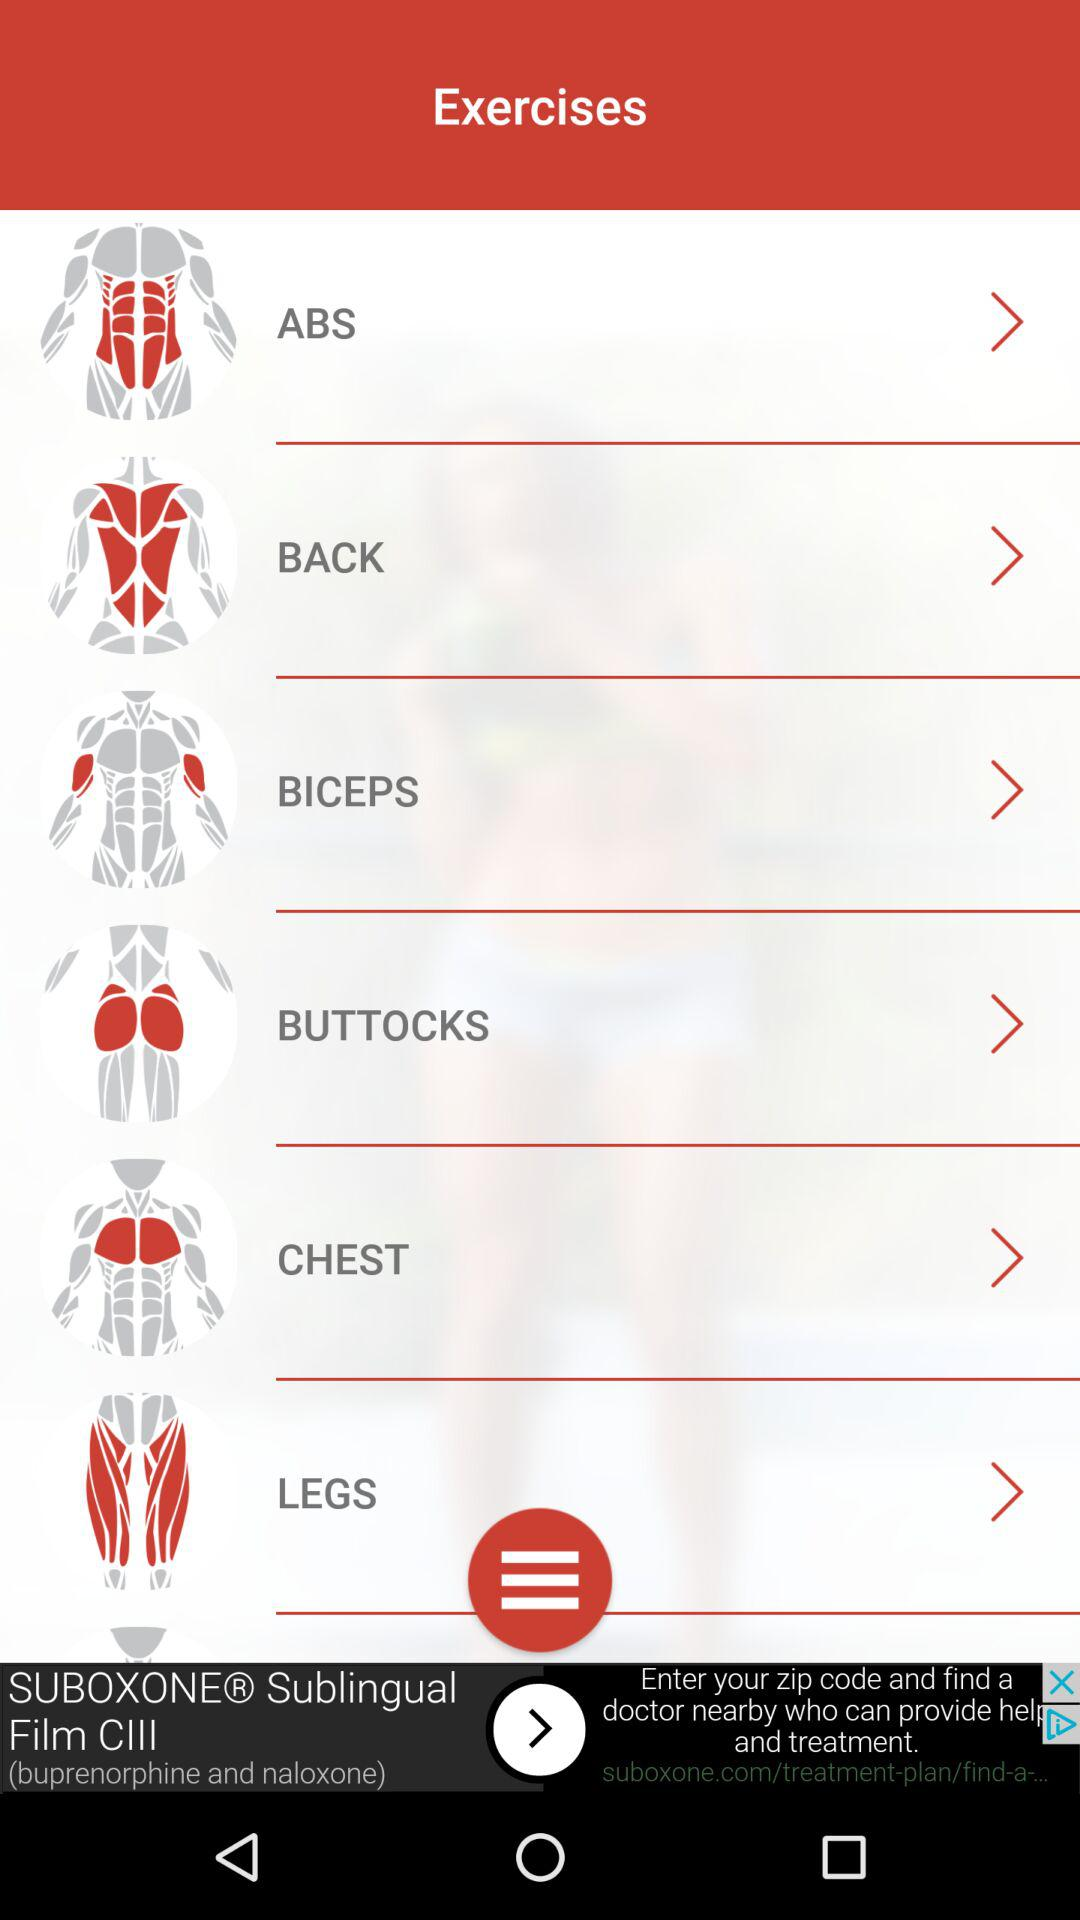What kinds of exercises do I have? The exercises are "ABS", "BACK", "BICEPS", "BUTTOCKS", "CHEST", and "LEGS". 